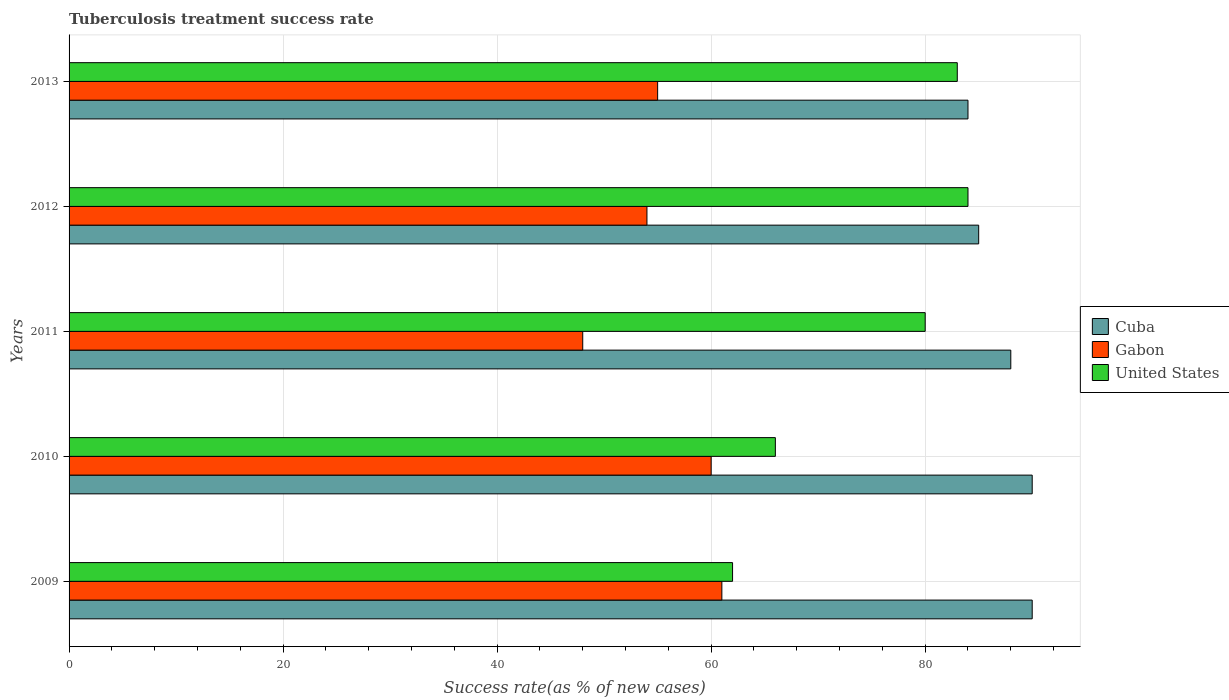How many different coloured bars are there?
Provide a short and direct response. 3. Are the number of bars per tick equal to the number of legend labels?
Your response must be concise. Yes. In how many cases, is the number of bars for a given year not equal to the number of legend labels?
Your response must be concise. 0. What is the tuberculosis treatment success rate in Gabon in 2011?
Keep it short and to the point. 48. Across all years, what is the minimum tuberculosis treatment success rate in Cuba?
Ensure brevity in your answer.  84. In which year was the tuberculosis treatment success rate in United States minimum?
Provide a succinct answer. 2009. What is the total tuberculosis treatment success rate in United States in the graph?
Your answer should be very brief. 375. What is the difference between the tuberculosis treatment success rate in United States in 2009 and that in 2012?
Your answer should be very brief. -22. What is the difference between the tuberculosis treatment success rate in United States in 2011 and the tuberculosis treatment success rate in Cuba in 2012?
Give a very brief answer. -5. In the year 2011, what is the difference between the tuberculosis treatment success rate in Cuba and tuberculosis treatment success rate in United States?
Provide a short and direct response. 8. In how many years, is the tuberculosis treatment success rate in Cuba greater than 52 %?
Provide a succinct answer. 5. What is the ratio of the tuberculosis treatment success rate in Gabon in 2009 to that in 2011?
Provide a short and direct response. 1.27. What is the difference between the highest and the second highest tuberculosis treatment success rate in United States?
Keep it short and to the point. 1. What is the difference between the highest and the lowest tuberculosis treatment success rate in United States?
Keep it short and to the point. 22. In how many years, is the tuberculosis treatment success rate in Cuba greater than the average tuberculosis treatment success rate in Cuba taken over all years?
Ensure brevity in your answer.  3. Is the sum of the tuberculosis treatment success rate in Cuba in 2009 and 2013 greater than the maximum tuberculosis treatment success rate in Gabon across all years?
Offer a terse response. Yes. What does the 1st bar from the top in 2010 represents?
Give a very brief answer. United States. What does the 3rd bar from the bottom in 2010 represents?
Your answer should be very brief. United States. Is it the case that in every year, the sum of the tuberculosis treatment success rate in United States and tuberculosis treatment success rate in Gabon is greater than the tuberculosis treatment success rate in Cuba?
Make the answer very short. Yes. How many bars are there?
Give a very brief answer. 15. What is the difference between two consecutive major ticks on the X-axis?
Give a very brief answer. 20. Does the graph contain any zero values?
Your answer should be compact. No. Does the graph contain grids?
Keep it short and to the point. Yes. How many legend labels are there?
Provide a short and direct response. 3. What is the title of the graph?
Make the answer very short. Tuberculosis treatment success rate. What is the label or title of the X-axis?
Ensure brevity in your answer.  Success rate(as % of new cases). What is the label or title of the Y-axis?
Your answer should be compact. Years. What is the Success rate(as % of new cases) of Cuba in 2009?
Your answer should be compact. 90. What is the Success rate(as % of new cases) in United States in 2009?
Make the answer very short. 62. What is the Success rate(as % of new cases) of Cuba in 2011?
Offer a terse response. 88. What is the Success rate(as % of new cases) of Gabon in 2011?
Your answer should be compact. 48. What is the Success rate(as % of new cases) of United States in 2011?
Give a very brief answer. 80. What is the Success rate(as % of new cases) in Cuba in 2012?
Make the answer very short. 85. What is the Success rate(as % of new cases) in United States in 2012?
Your answer should be compact. 84. What is the Success rate(as % of new cases) in Cuba in 2013?
Give a very brief answer. 84. What is the Success rate(as % of new cases) in Gabon in 2013?
Offer a very short reply. 55. Across all years, what is the maximum Success rate(as % of new cases) of Cuba?
Give a very brief answer. 90. Across all years, what is the maximum Success rate(as % of new cases) of United States?
Offer a very short reply. 84. Across all years, what is the minimum Success rate(as % of new cases) of Gabon?
Your answer should be very brief. 48. What is the total Success rate(as % of new cases) in Cuba in the graph?
Give a very brief answer. 437. What is the total Success rate(as % of new cases) of Gabon in the graph?
Your response must be concise. 278. What is the total Success rate(as % of new cases) in United States in the graph?
Make the answer very short. 375. What is the difference between the Success rate(as % of new cases) in Gabon in 2009 and that in 2010?
Your response must be concise. 1. What is the difference between the Success rate(as % of new cases) of United States in 2009 and that in 2010?
Keep it short and to the point. -4. What is the difference between the Success rate(as % of new cases) in United States in 2009 and that in 2011?
Your answer should be compact. -18. What is the difference between the Success rate(as % of new cases) in Cuba in 2009 and that in 2012?
Keep it short and to the point. 5. What is the difference between the Success rate(as % of new cases) of Gabon in 2009 and that in 2012?
Keep it short and to the point. 7. What is the difference between the Success rate(as % of new cases) in Gabon in 2009 and that in 2013?
Offer a terse response. 6. What is the difference between the Success rate(as % of new cases) of Cuba in 2010 and that in 2011?
Provide a succinct answer. 2. What is the difference between the Success rate(as % of new cases) in United States in 2010 and that in 2011?
Your answer should be compact. -14. What is the difference between the Success rate(as % of new cases) of Gabon in 2010 and that in 2012?
Give a very brief answer. 6. What is the difference between the Success rate(as % of new cases) in Gabon in 2010 and that in 2013?
Keep it short and to the point. 5. What is the difference between the Success rate(as % of new cases) of Cuba in 2011 and that in 2013?
Offer a terse response. 4. What is the difference between the Success rate(as % of new cases) in Gabon in 2011 and that in 2013?
Your answer should be very brief. -7. What is the difference between the Success rate(as % of new cases) of United States in 2011 and that in 2013?
Keep it short and to the point. -3. What is the difference between the Success rate(as % of new cases) in United States in 2012 and that in 2013?
Make the answer very short. 1. What is the difference between the Success rate(as % of new cases) of Cuba in 2009 and the Success rate(as % of new cases) of Gabon in 2010?
Give a very brief answer. 30. What is the difference between the Success rate(as % of new cases) in Gabon in 2009 and the Success rate(as % of new cases) in United States in 2010?
Provide a short and direct response. -5. What is the difference between the Success rate(as % of new cases) in Cuba in 2009 and the Success rate(as % of new cases) in Gabon in 2011?
Offer a very short reply. 42. What is the difference between the Success rate(as % of new cases) of Cuba in 2009 and the Success rate(as % of new cases) of United States in 2011?
Provide a succinct answer. 10. What is the difference between the Success rate(as % of new cases) of Cuba in 2009 and the Success rate(as % of new cases) of Gabon in 2012?
Offer a terse response. 36. What is the difference between the Success rate(as % of new cases) of Gabon in 2009 and the Success rate(as % of new cases) of United States in 2012?
Your answer should be very brief. -23. What is the difference between the Success rate(as % of new cases) of Gabon in 2009 and the Success rate(as % of new cases) of United States in 2013?
Ensure brevity in your answer.  -22. What is the difference between the Success rate(as % of new cases) of Cuba in 2010 and the Success rate(as % of new cases) of Gabon in 2011?
Make the answer very short. 42. What is the difference between the Success rate(as % of new cases) of Cuba in 2010 and the Success rate(as % of new cases) of United States in 2011?
Offer a very short reply. 10. What is the difference between the Success rate(as % of new cases) in Cuba in 2010 and the Success rate(as % of new cases) in Gabon in 2012?
Your answer should be compact. 36. What is the difference between the Success rate(as % of new cases) in Cuba in 2010 and the Success rate(as % of new cases) in United States in 2012?
Offer a terse response. 6. What is the difference between the Success rate(as % of new cases) of Cuba in 2010 and the Success rate(as % of new cases) of Gabon in 2013?
Your answer should be very brief. 35. What is the difference between the Success rate(as % of new cases) of Gabon in 2010 and the Success rate(as % of new cases) of United States in 2013?
Offer a very short reply. -23. What is the difference between the Success rate(as % of new cases) of Cuba in 2011 and the Success rate(as % of new cases) of Gabon in 2012?
Provide a succinct answer. 34. What is the difference between the Success rate(as % of new cases) in Cuba in 2011 and the Success rate(as % of new cases) in United States in 2012?
Give a very brief answer. 4. What is the difference between the Success rate(as % of new cases) of Gabon in 2011 and the Success rate(as % of new cases) of United States in 2012?
Offer a terse response. -36. What is the difference between the Success rate(as % of new cases) in Cuba in 2011 and the Success rate(as % of new cases) in Gabon in 2013?
Keep it short and to the point. 33. What is the difference between the Success rate(as % of new cases) of Gabon in 2011 and the Success rate(as % of new cases) of United States in 2013?
Make the answer very short. -35. What is the difference between the Success rate(as % of new cases) of Gabon in 2012 and the Success rate(as % of new cases) of United States in 2013?
Provide a short and direct response. -29. What is the average Success rate(as % of new cases) of Cuba per year?
Offer a terse response. 87.4. What is the average Success rate(as % of new cases) of Gabon per year?
Offer a very short reply. 55.6. What is the average Success rate(as % of new cases) in United States per year?
Offer a terse response. 75. In the year 2009, what is the difference between the Success rate(as % of new cases) in Cuba and Success rate(as % of new cases) in Gabon?
Keep it short and to the point. 29. In the year 2009, what is the difference between the Success rate(as % of new cases) of Cuba and Success rate(as % of new cases) of United States?
Offer a very short reply. 28. In the year 2010, what is the difference between the Success rate(as % of new cases) of Cuba and Success rate(as % of new cases) of Gabon?
Ensure brevity in your answer.  30. In the year 2010, what is the difference between the Success rate(as % of new cases) of Cuba and Success rate(as % of new cases) of United States?
Your response must be concise. 24. In the year 2011, what is the difference between the Success rate(as % of new cases) of Cuba and Success rate(as % of new cases) of Gabon?
Make the answer very short. 40. In the year 2011, what is the difference between the Success rate(as % of new cases) in Cuba and Success rate(as % of new cases) in United States?
Provide a succinct answer. 8. In the year 2011, what is the difference between the Success rate(as % of new cases) of Gabon and Success rate(as % of new cases) of United States?
Make the answer very short. -32. In the year 2012, what is the difference between the Success rate(as % of new cases) of Cuba and Success rate(as % of new cases) of Gabon?
Your answer should be compact. 31. In the year 2012, what is the difference between the Success rate(as % of new cases) of Gabon and Success rate(as % of new cases) of United States?
Make the answer very short. -30. In the year 2013, what is the difference between the Success rate(as % of new cases) in Gabon and Success rate(as % of new cases) in United States?
Offer a very short reply. -28. What is the ratio of the Success rate(as % of new cases) in Cuba in 2009 to that in 2010?
Keep it short and to the point. 1. What is the ratio of the Success rate(as % of new cases) of Gabon in 2009 to that in 2010?
Keep it short and to the point. 1.02. What is the ratio of the Success rate(as % of new cases) in United States in 2009 to that in 2010?
Your answer should be compact. 0.94. What is the ratio of the Success rate(as % of new cases) of Cuba in 2009 to that in 2011?
Provide a short and direct response. 1.02. What is the ratio of the Success rate(as % of new cases) of Gabon in 2009 to that in 2011?
Provide a short and direct response. 1.27. What is the ratio of the Success rate(as % of new cases) in United States in 2009 to that in 2011?
Provide a short and direct response. 0.78. What is the ratio of the Success rate(as % of new cases) in Cuba in 2009 to that in 2012?
Give a very brief answer. 1.06. What is the ratio of the Success rate(as % of new cases) of Gabon in 2009 to that in 2012?
Your response must be concise. 1.13. What is the ratio of the Success rate(as % of new cases) of United States in 2009 to that in 2012?
Keep it short and to the point. 0.74. What is the ratio of the Success rate(as % of new cases) in Cuba in 2009 to that in 2013?
Give a very brief answer. 1.07. What is the ratio of the Success rate(as % of new cases) in Gabon in 2009 to that in 2013?
Ensure brevity in your answer.  1.11. What is the ratio of the Success rate(as % of new cases) in United States in 2009 to that in 2013?
Your response must be concise. 0.75. What is the ratio of the Success rate(as % of new cases) in Cuba in 2010 to that in 2011?
Ensure brevity in your answer.  1.02. What is the ratio of the Success rate(as % of new cases) in Gabon in 2010 to that in 2011?
Your answer should be compact. 1.25. What is the ratio of the Success rate(as % of new cases) in United States in 2010 to that in 2011?
Provide a succinct answer. 0.82. What is the ratio of the Success rate(as % of new cases) of Cuba in 2010 to that in 2012?
Offer a terse response. 1.06. What is the ratio of the Success rate(as % of new cases) of United States in 2010 to that in 2012?
Keep it short and to the point. 0.79. What is the ratio of the Success rate(as % of new cases) of Cuba in 2010 to that in 2013?
Keep it short and to the point. 1.07. What is the ratio of the Success rate(as % of new cases) in United States in 2010 to that in 2013?
Your answer should be compact. 0.8. What is the ratio of the Success rate(as % of new cases) in Cuba in 2011 to that in 2012?
Offer a terse response. 1.04. What is the ratio of the Success rate(as % of new cases) of Gabon in 2011 to that in 2012?
Your answer should be very brief. 0.89. What is the ratio of the Success rate(as % of new cases) of Cuba in 2011 to that in 2013?
Provide a short and direct response. 1.05. What is the ratio of the Success rate(as % of new cases) in Gabon in 2011 to that in 2013?
Ensure brevity in your answer.  0.87. What is the ratio of the Success rate(as % of new cases) of United States in 2011 to that in 2013?
Offer a terse response. 0.96. What is the ratio of the Success rate(as % of new cases) in Cuba in 2012 to that in 2013?
Your response must be concise. 1.01. What is the ratio of the Success rate(as % of new cases) in Gabon in 2012 to that in 2013?
Offer a very short reply. 0.98. What is the ratio of the Success rate(as % of new cases) of United States in 2012 to that in 2013?
Offer a terse response. 1.01. What is the difference between the highest and the second highest Success rate(as % of new cases) in Cuba?
Your answer should be very brief. 0. What is the difference between the highest and the second highest Success rate(as % of new cases) in Gabon?
Make the answer very short. 1. What is the difference between the highest and the lowest Success rate(as % of new cases) of Cuba?
Your answer should be compact. 6. What is the difference between the highest and the lowest Success rate(as % of new cases) of Gabon?
Give a very brief answer. 13. What is the difference between the highest and the lowest Success rate(as % of new cases) in United States?
Your response must be concise. 22. 